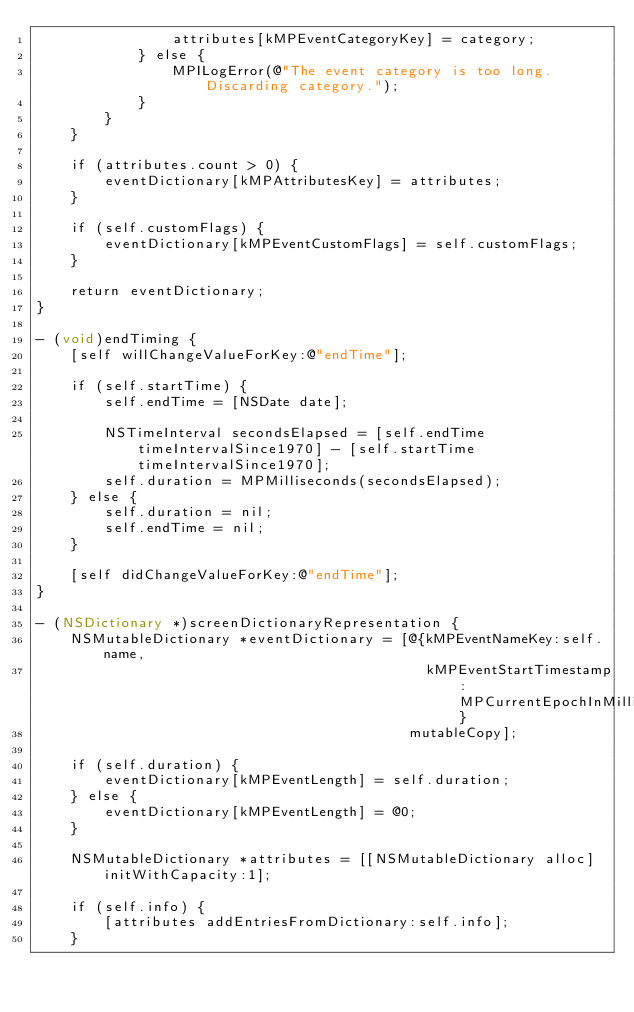<code> <loc_0><loc_0><loc_500><loc_500><_ObjectiveC_>                attributes[kMPEventCategoryKey] = category;
            } else {
                MPILogError(@"The event category is too long. Discarding category.");
            }
        }
    }
    
    if (attributes.count > 0) {
        eventDictionary[kMPAttributesKey] = attributes;
    }
    
    if (self.customFlags) {
        eventDictionary[kMPEventCustomFlags] = self.customFlags;
    }
    
    return eventDictionary;
}

- (void)endTiming {
    [self willChangeValueForKey:@"endTime"];
    
    if (self.startTime) {
        self.endTime = [NSDate date];
        
        NSTimeInterval secondsElapsed = [self.endTime timeIntervalSince1970] - [self.startTime timeIntervalSince1970];
        self.duration = MPMilliseconds(secondsElapsed);
    } else {
        self.duration = nil;
        self.endTime = nil;
    }
    
    [self didChangeValueForKey:@"endTime"];
}

- (NSDictionary *)screenDictionaryRepresentation {
    NSMutableDictionary *eventDictionary = [@{kMPEventNameKey:self.name,
                                              kMPEventStartTimestamp:MPCurrentEpochInMilliseconds}
                                            mutableCopy];
    
    if (self.duration) {
        eventDictionary[kMPEventLength] = self.duration;
    } else {
        eventDictionary[kMPEventLength] = @0;
    }
    
    NSMutableDictionary *attributes = [[NSMutableDictionary alloc] initWithCapacity:1];
    
    if (self.info) {
        [attributes addEntriesFromDictionary:self.info];
    }
</code> 